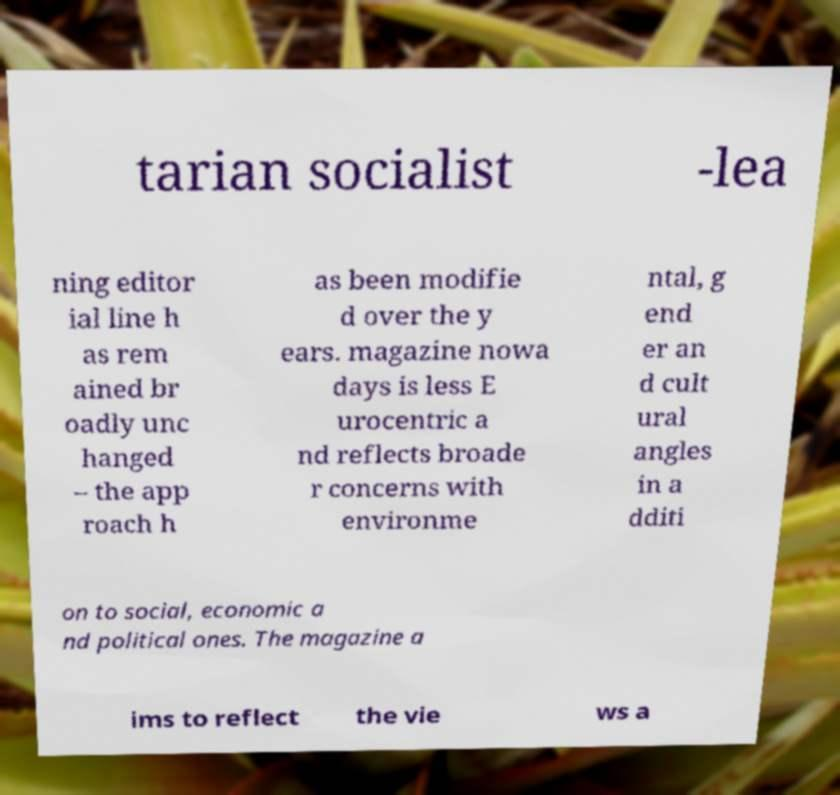Please read and relay the text visible in this image. What does it say? tarian socialist -lea ning editor ial line h as rem ained br oadly unc hanged – the app roach h as been modifie d over the y ears. magazine nowa days is less E urocentric a nd reflects broade r concerns with environme ntal, g end er an d cult ural angles in a dditi on to social, economic a nd political ones. The magazine a ims to reflect the vie ws a 